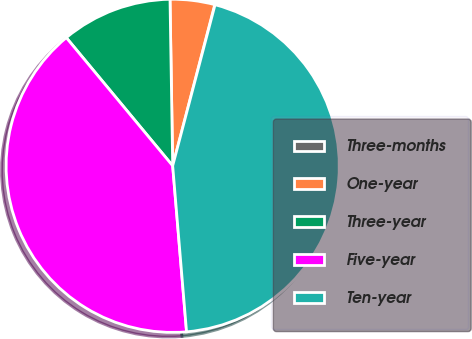Convert chart to OTSL. <chart><loc_0><loc_0><loc_500><loc_500><pie_chart><fcel>Three-months<fcel>One-year<fcel>Three-year<fcel>Five-year<fcel>Ten-year<nl><fcel>0.03%<fcel>4.32%<fcel>10.77%<fcel>40.3%<fcel>44.58%<nl></chart> 